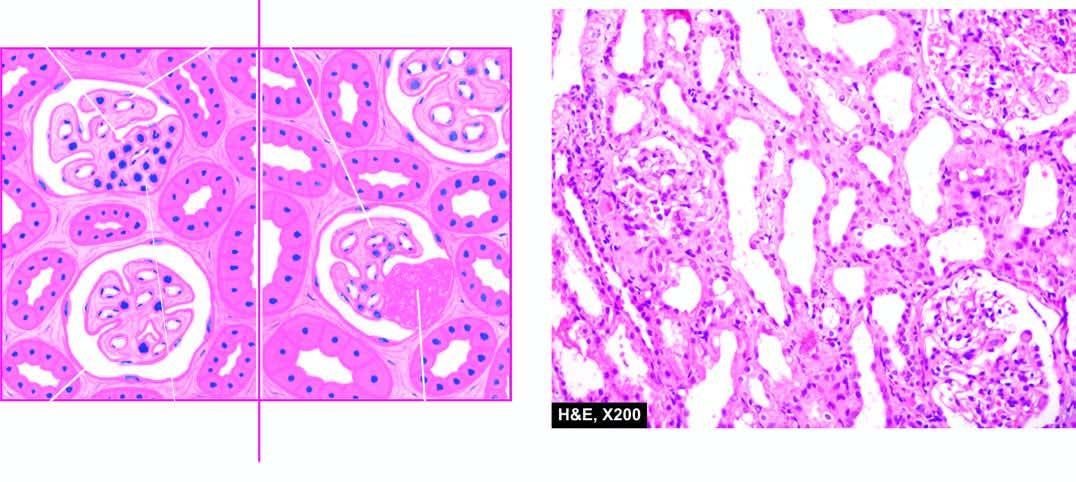re the features focal and segmental involvement of the glomeruli by sclerosis and hyalinosis and mesangial hypercellularity?
Answer the question using a single word or phrase. Yes 